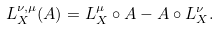Convert formula to latex. <formula><loc_0><loc_0><loc_500><loc_500>L _ { X } ^ { \nu , \mu } ( A ) = L _ { X } ^ { \mu } \circ A - A \circ L _ { X } ^ { \nu } .</formula> 